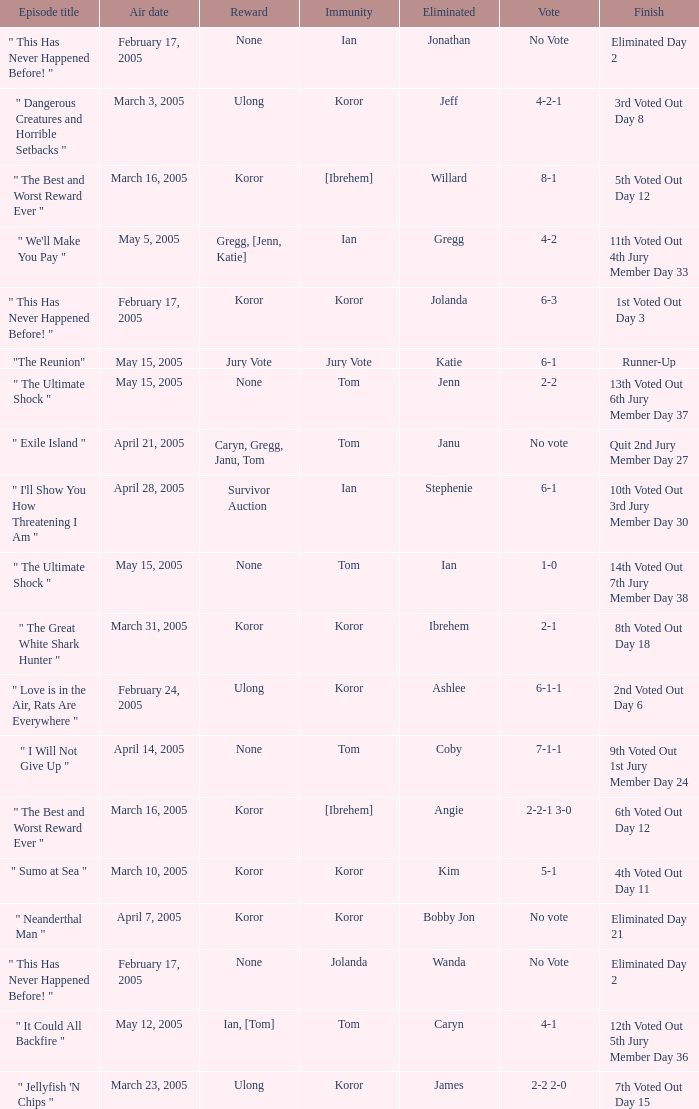What was the vote tally on the episode aired May 5, 2005? 4-2. Could you parse the entire table? {'header': ['Episode title', 'Air date', 'Reward', 'Immunity', 'Eliminated', 'Vote', 'Finish'], 'rows': [['" This Has Never Happened Before! "', 'February 17, 2005', 'None', 'Ian', 'Jonathan', 'No Vote', 'Eliminated Day 2'], ['" Dangerous Creatures and Horrible Setbacks "', 'March 3, 2005', 'Ulong', 'Koror', 'Jeff', '4-2-1', '3rd Voted Out Day 8'], ['" The Best and Worst Reward Ever "', 'March 16, 2005', 'Koror', '[Ibrehem]', 'Willard', '8-1', '5th Voted Out Day 12'], ['" We\'ll Make You Pay "', 'May 5, 2005', 'Gregg, [Jenn, Katie]', 'Ian', 'Gregg', '4-2', '11th Voted Out 4th Jury Member Day 33'], ['" This Has Never Happened Before! "', 'February 17, 2005', 'Koror', 'Koror', 'Jolanda', '6-3', '1st Voted Out Day 3'], ['"The Reunion"', 'May 15, 2005', 'Jury Vote', 'Jury Vote', 'Katie', '6-1', 'Runner-Up'], ['" The Ultimate Shock "', 'May 15, 2005', 'None', 'Tom', 'Jenn', '2-2', '13th Voted Out 6th Jury Member Day 37'], ['" Exile Island "', 'April 21, 2005', 'Caryn, Gregg, Janu, Tom', 'Tom', 'Janu', 'No vote', 'Quit 2nd Jury Member Day 27'], ['" I\'ll Show You How Threatening I Am "', 'April 28, 2005', 'Survivor Auction', 'Ian', 'Stephenie', '6-1', '10th Voted Out 3rd Jury Member Day 30'], ['" The Ultimate Shock "', 'May 15, 2005', 'None', 'Tom', 'Ian', '1-0', '14th Voted Out 7th Jury Member Day 38'], ['" The Great White Shark Hunter "', 'March 31, 2005', 'Koror', 'Koror', 'Ibrehem', '2-1', '8th Voted Out Day 18'], ['" Love is in the Air, Rats Are Everywhere "', 'February 24, 2005', 'Ulong', 'Koror', 'Ashlee', '6-1-1', '2nd Voted Out Day 6'], ['" I Will Not Give Up "', 'April 14, 2005', 'None', 'Tom', 'Coby', '7-1-1', '9th Voted Out 1st Jury Member Day 24'], ['" The Best and Worst Reward Ever "', 'March 16, 2005', 'Koror', '[Ibrehem]', 'Angie', '2-2-1 3-0', '6th Voted Out Day 12'], ['" Sumo at Sea "', 'March 10, 2005', 'Koror', 'Koror', 'Kim', '5-1', '4th Voted Out Day 11'], ['" Neanderthal Man "', 'April 7, 2005', 'Koror', 'Koror', 'Bobby Jon', 'No vote', 'Eliminated Day 21'], ['" This Has Never Happened Before! "', 'February 17, 2005', 'None', 'Jolanda', 'Wanda', 'No Vote', 'Eliminated Day 2'], ['" It Could All Backfire "', 'May 12, 2005', 'Ian, [Tom]', 'Tom', 'Caryn', '4-1', '12th Voted Out 5th Jury Member Day 36'], ['" Jellyfish \'N Chips "', 'March 23, 2005', 'Ulong', 'Koror', 'James', '2-2 2-0', '7th Voted Out Day 15']]} 